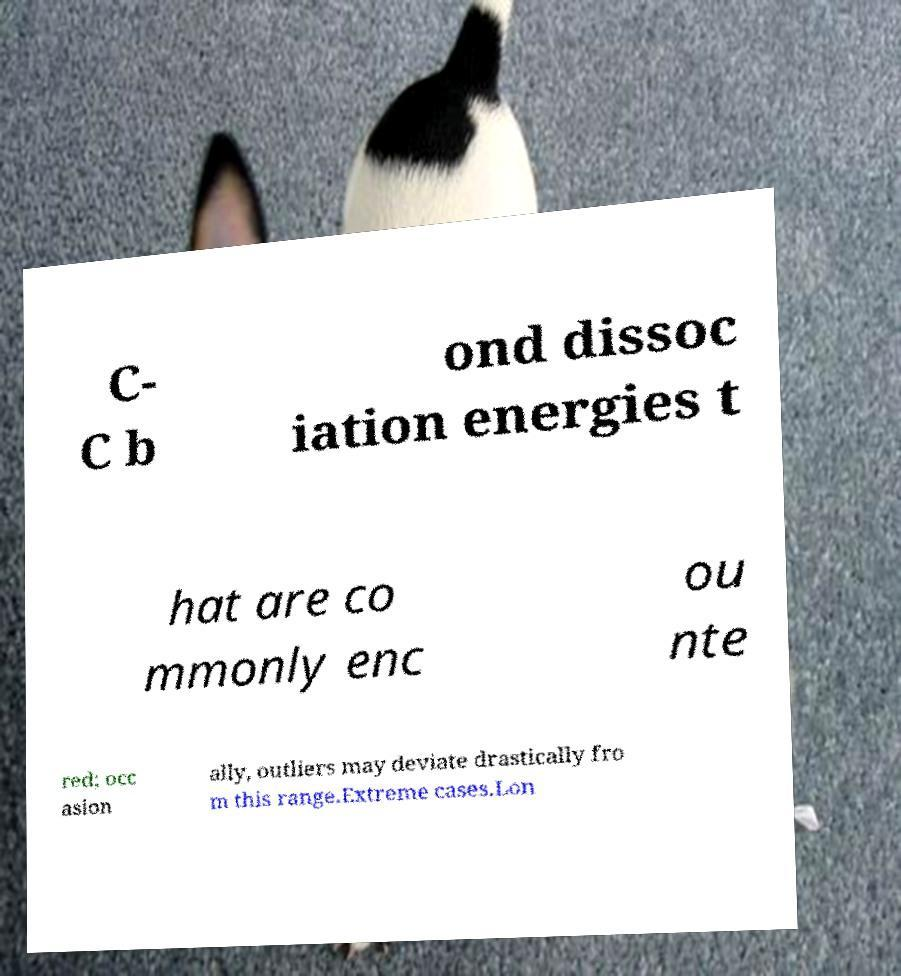Please identify and transcribe the text found in this image. C- C b ond dissoc iation energies t hat are co mmonly enc ou nte red; occ asion ally, outliers may deviate drastically fro m this range.Extreme cases.Lon 